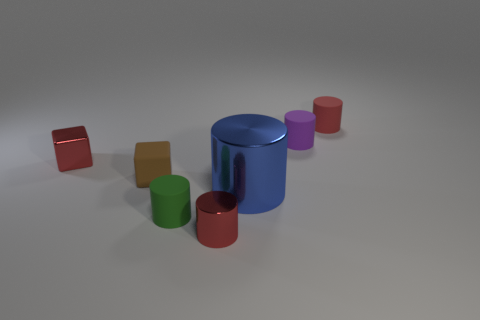Subtract all large metallic cylinders. How many cylinders are left? 4 Subtract all red cylinders. How many cylinders are left? 3 Subtract 2 blocks. How many blocks are left? 0 Add 3 big red cylinders. How many objects exist? 10 Subtract all green spheres. How many cyan cubes are left? 0 Subtract all red shiny cylinders. Subtract all small shiny blocks. How many objects are left? 5 Add 2 tiny shiny cubes. How many tiny shiny cubes are left? 3 Add 7 small brown shiny cylinders. How many small brown shiny cylinders exist? 7 Subtract 0 blue cubes. How many objects are left? 7 Subtract all blocks. How many objects are left? 5 